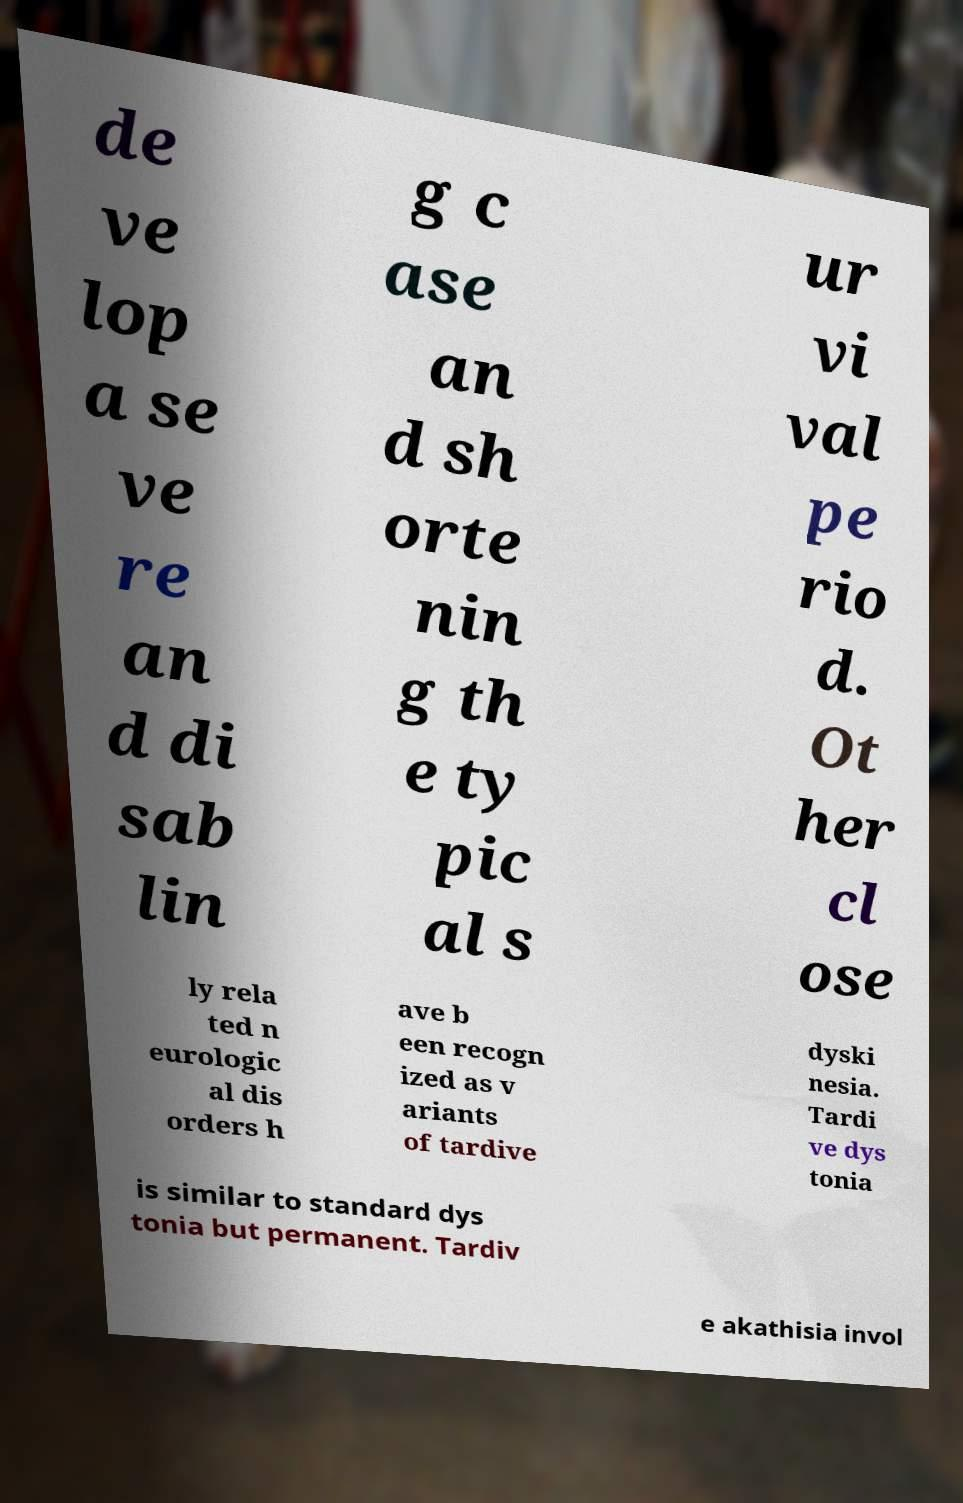For documentation purposes, I need the text within this image transcribed. Could you provide that? de ve lop a se ve re an d di sab lin g c ase an d sh orte nin g th e ty pic al s ur vi val pe rio d. Ot her cl ose ly rela ted n eurologic al dis orders h ave b een recogn ized as v ariants of tardive dyski nesia. Tardi ve dys tonia is similar to standard dys tonia but permanent. Tardiv e akathisia invol 